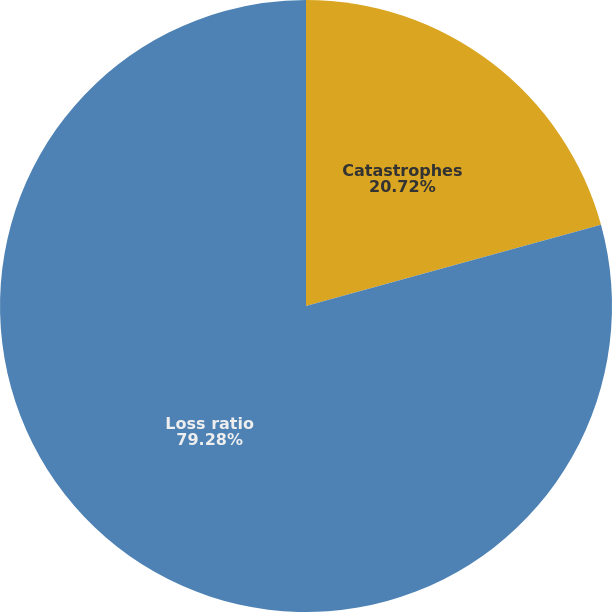<chart> <loc_0><loc_0><loc_500><loc_500><pie_chart><fcel>Catastrophes<fcel>Loss ratio<nl><fcel>20.72%<fcel>79.28%<nl></chart> 